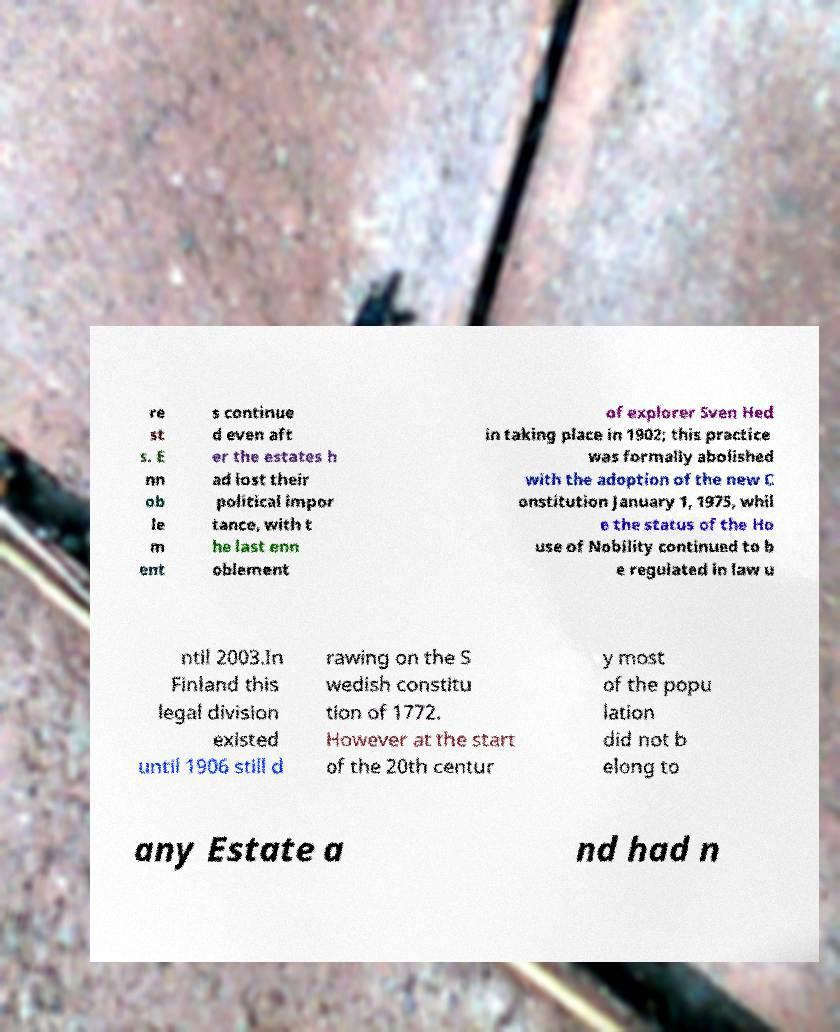For documentation purposes, I need the text within this image transcribed. Could you provide that? re st s. E nn ob le m ent s continue d even aft er the estates h ad lost their political impor tance, with t he last enn oblement of explorer Sven Hed in taking place in 1902; this practice was formally abolished with the adoption of the new C onstitution January 1, 1975, whil e the status of the Ho use of Nobility continued to b e regulated in law u ntil 2003.In Finland this legal division existed until 1906 still d rawing on the S wedish constitu tion of 1772. However at the start of the 20th centur y most of the popu lation did not b elong to any Estate a nd had n 